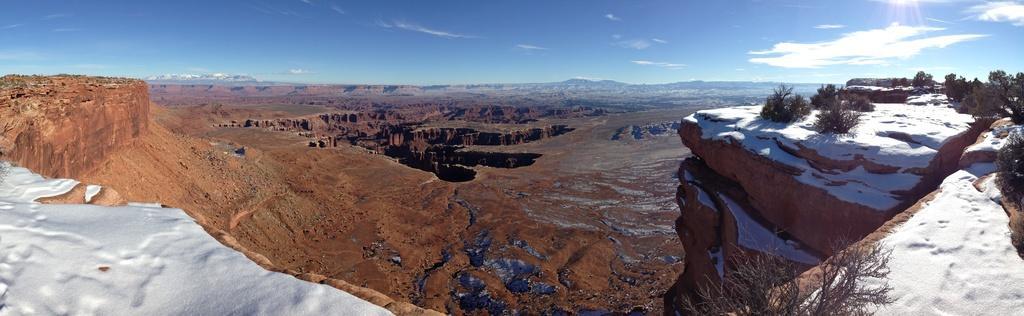Please provide a concise description of this image. There are hills. On the right side there are trees. On the ground it is covered with snow. Also on the left side there is snow. In the background there is sky with clouds. 